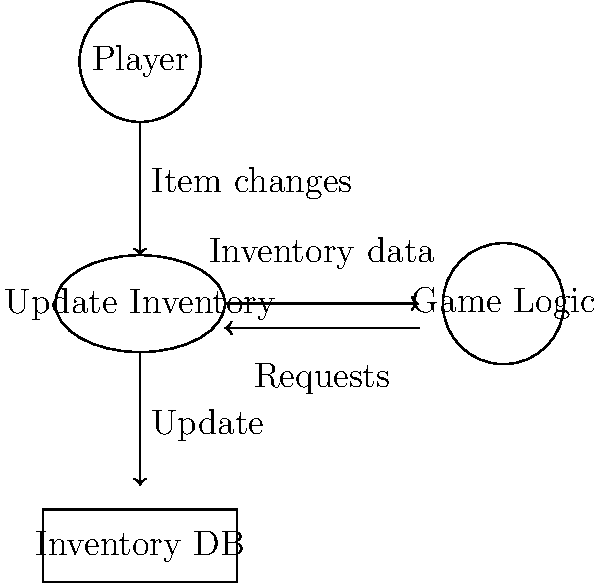In the data flow diagram for a game's inventory management system shown above, which component serves as the central process for managing inventory updates? To identify the central process for managing inventory updates in this data flow diagram, let's analyze the components and their interactions:

1. The diagram shows four main components: Player, Update Inventory, Inventory DB, and Game Logic.

2. The "Update Inventory" component is represented as an ellipse, which typically denotes a process in data flow diagrams.

3. We can observe that:
   a. The Player sends "Item changes" to the "Update Inventory" process.
   b. The "Update Inventory" process sends "Update" information to the Inventory DB.
   c. The "Update Inventory" process exchanges data with the Game Logic component.

4. The "Update Inventory" process is centrally located and interacts with all other components in the system.

5. It receives input from the Player, updates the database, and communicates with the Game Logic, making it the focal point for inventory management operations.

Given these observations, we can conclude that the "Update Inventory" process serves as the central component for managing inventory updates in this system.
Answer: Update Inventory 